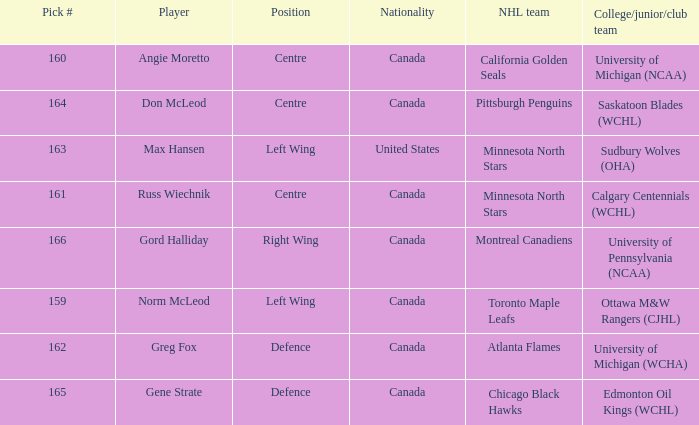What is the nationality of the player from the University of Michigan (NCAA)? Canada. 